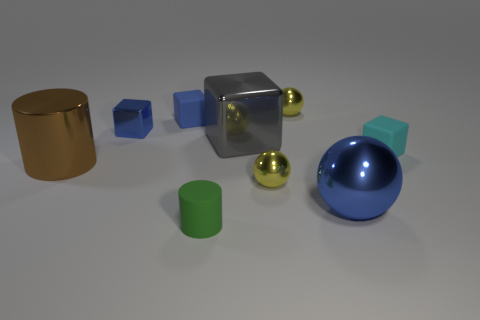What number of small things are either cyan matte cubes or cubes?
Offer a very short reply. 3. Are there any small brown matte spheres?
Give a very brief answer. No. Are there more small cyan matte objects in front of the small blue metal object than blue metal balls behind the gray metal block?
Offer a terse response. Yes. What is the color of the shiny thing that is behind the rubber block that is behind the big gray metal cube?
Keep it short and to the point. Yellow. Is there a metallic cube that has the same color as the large metal sphere?
Keep it short and to the point. Yes. How big is the yellow metal ball in front of the yellow thing that is right of the tiny yellow shiny ball in front of the gray metallic block?
Offer a very short reply. Small. What shape is the tiny green object?
Make the answer very short. Cylinder. There is a metallic block that is the same color as the large metal ball; what is its size?
Offer a terse response. Small. There is a blue metal object in front of the big gray shiny block; how many large cylinders are on the left side of it?
Offer a terse response. 1. How many other things are the same material as the tiny cyan block?
Offer a very short reply. 2. 